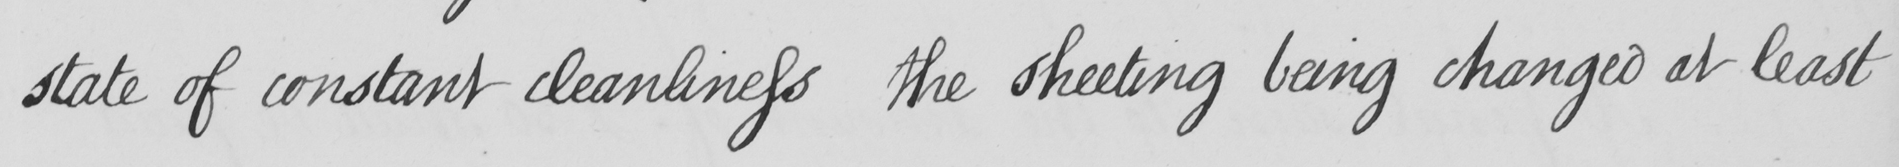Can you read and transcribe this handwriting? state of constant cleanliness the sheeting being changed at least 